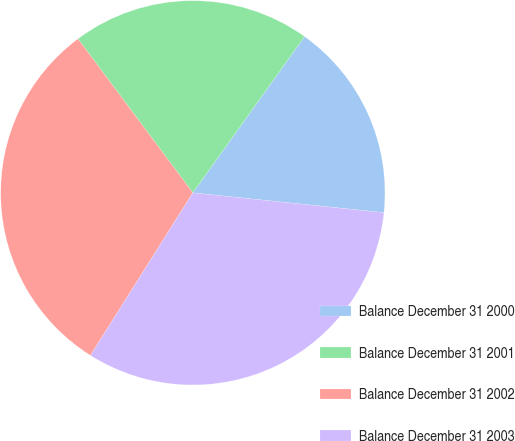Convert chart to OTSL. <chart><loc_0><loc_0><loc_500><loc_500><pie_chart><fcel>Balance December 31 2000<fcel>Balance December 31 2001<fcel>Balance December 31 2002<fcel>Balance December 31 2003<nl><fcel>16.77%<fcel>20.08%<fcel>30.85%<fcel>32.3%<nl></chart> 